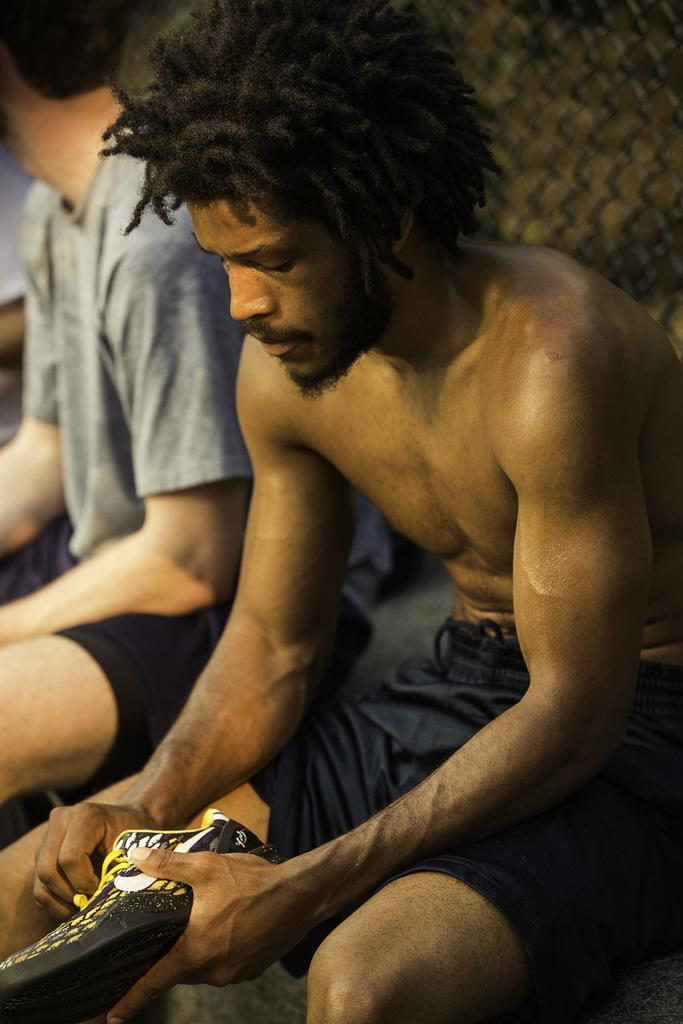What is the person in the image holding? The person is holding a shoe in the image. Can you describe the position of the other person in the image? There is another person sitting on the left side of the image. What can be seen in the background of the image? There is fencing in the background of the image. What type of eggs can be seen being played on the drum in the image? There are no eggs or drums present in the image. What type of voyage is the person taking in the image? The image does not depict a voyage; it shows two people sitting and holding a shoe. 